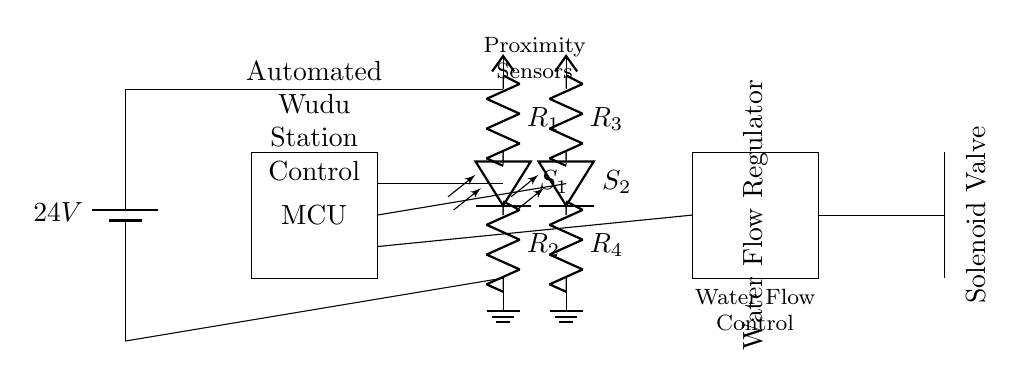What is the voltage source in this circuit? The voltage source is a battery indicated at the start of the circuit, labeled as 24V. This is the potential difference that powers the entire circuit.
Answer: 24V What do the proximity sensors detect? The proximity sensors, labeled as S1 and S2, are designed to detect the presence of a person near the automated wudu station, triggering the system for water flow.
Answer: Presence of a person How many resistors are used in the circuit? The circuit contains four resistors labeled as R1, R2, R3, and R4, which are connected with the proximity sensors. These resistors serve various purposes, likely including signal conditioning for sensor outputs.
Answer: Four What is the purpose of the solenoid valve in this circuit? The solenoid valve in the circuit controls the flow of water. When the proximity sensors detect presence, the valve opens or closes based on the control signals from the microcontroller, allowing or stopping water flow.
Answer: Control water flow Which component regulates the water flow? The water flow regulator, labeled specifically in the circuit diagram, is used to manage the amount of water that flows through the system, ensuring appropriate water delivery for ablution.
Answer: Water Flow Regulator How does the microcontroller interact with the proximity sensors? The microcontroller receives input signals from the proximity sensors (S1 and S2), processes these signals, and controls outputs like the solenoid valve to manage operations based on detected presence.
Answer: Controls solenoid valve What triggers the solenoid valve to open? The solenoid valve opens based on signals from the microcontroller, which is triggered by the proximity sensors detecting a person nearby. This automation ensures efficient water use during ablution.
Answer: Proximity sensor signals 